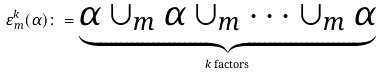Convert formula to latex. <formula><loc_0><loc_0><loc_500><loc_500>\varepsilon ^ { k } _ { m } ( \alpha ) \colon = \underbrace { \alpha \cup _ { m } \alpha \cup _ { m } \dots \cup _ { m } \alpha } _ { k \text { factors} }</formula> 